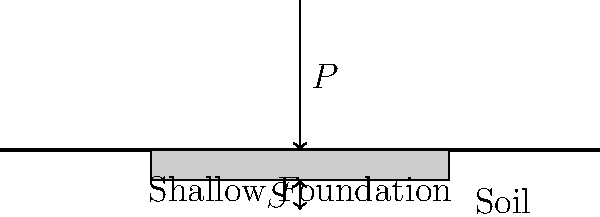In honor of Jean d'Ormesson's attention to detail in his literary works, consider a shallow foundation subjected to a vertical load $P = 500 \text{ kN}$. The foundation has dimensions of 2 m × 2 m and is placed on a cohesionless soil with a modulus of elasticity $E_s = 50 \text{ MPa}$ and Poisson's ratio $\nu = 0.3$. Using the elastic theory method, calculate the immediate settlement $S$ (in mm) of the foundation. Assume the influence factor $I_f = 0.95$ and the foundation is perfectly flexible. To solve this problem, we'll use the elastic theory method for calculating the immediate settlement of a shallow foundation. The formula for settlement is:

$$ S = \frac{P(1-\nu^2)}{E_s B} I_f $$

Where:
$S$ = Settlement
$P$ = Applied load
$\nu$ = Poisson's ratio of the soil
$E_s$ = Elastic modulus of the soil
$B$ = Width of the foundation
$I_f$ = Influence factor

Let's follow these steps:

1) Identify the given values:
   $P = 500 \text{ kN}$
   $\nu = 0.3$
   $E_s = 50 \text{ MPa} = 50,000 \text{ kPa}$
   $B = 2 \text{ m}$
   $I_f = 0.95$

2) Substitute these values into the formula:

   $$ S = \frac{500 \text{ kN} \cdot (1-0.3^2)}{50,000 \text{ kPa} \cdot 2 \text{ m}} \cdot 0.95 $$

3) Calculate $(1-0.3^2) = 0.91$

4) Perform the calculation:

   $$ S = \frac{500 \cdot 0.91}{50,000 \cdot 2} \cdot 0.95 = 0.004313 \text{ m} $$

5) Convert the result to millimeters:

   $$ S = 0.004313 \text{ m} \cdot 1000 \text{ mm/m} = 4.313 \text{ mm} $$

6) Round to two decimal places:

   $$ S \approx 4.31 \text{ mm} $$
Answer: 4.31 mm 